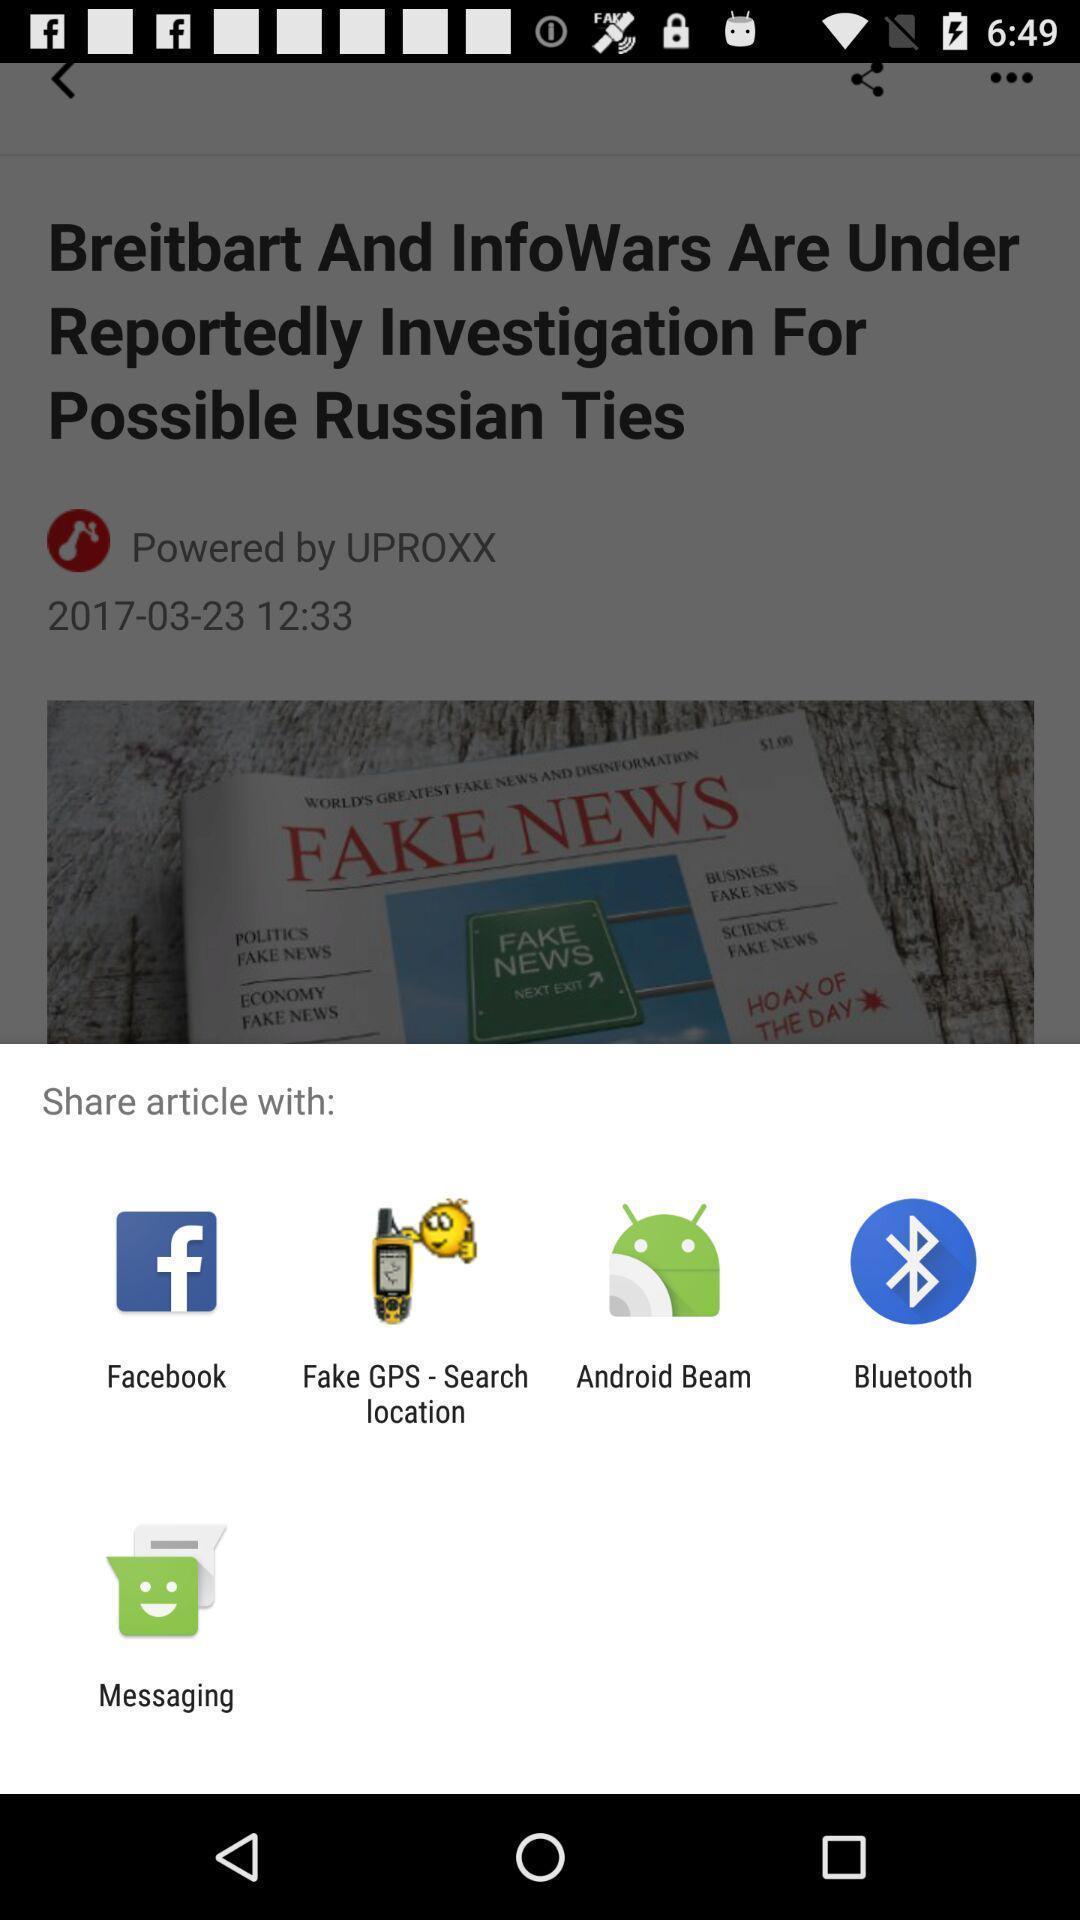Describe the key features of this screenshot. Popup of the different applications to share articles. 